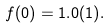Convert formula to latex. <formula><loc_0><loc_0><loc_500><loc_500>f ( 0 ) = 1 . 0 ( 1 ) .</formula> 